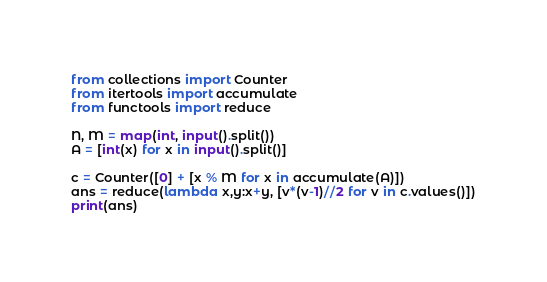<code> <loc_0><loc_0><loc_500><loc_500><_Python_>from collections import Counter
from itertools import accumulate
from functools import reduce

N, M = map(int, input().split())
A = [int(x) for x in input().split()]

c = Counter([0] + [x % M for x in accumulate(A)])
ans = reduce(lambda x,y:x+y, [v*(v-1)//2 for v in c.values()])
print(ans)
</code> 